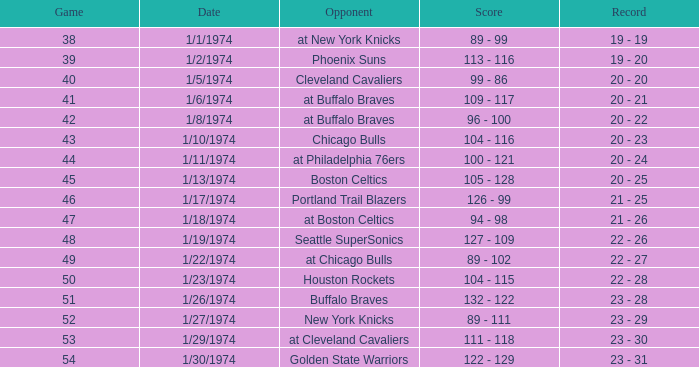On january 27, 1974, what was the outcome following the completion of the 51st game? 23 - 29. 